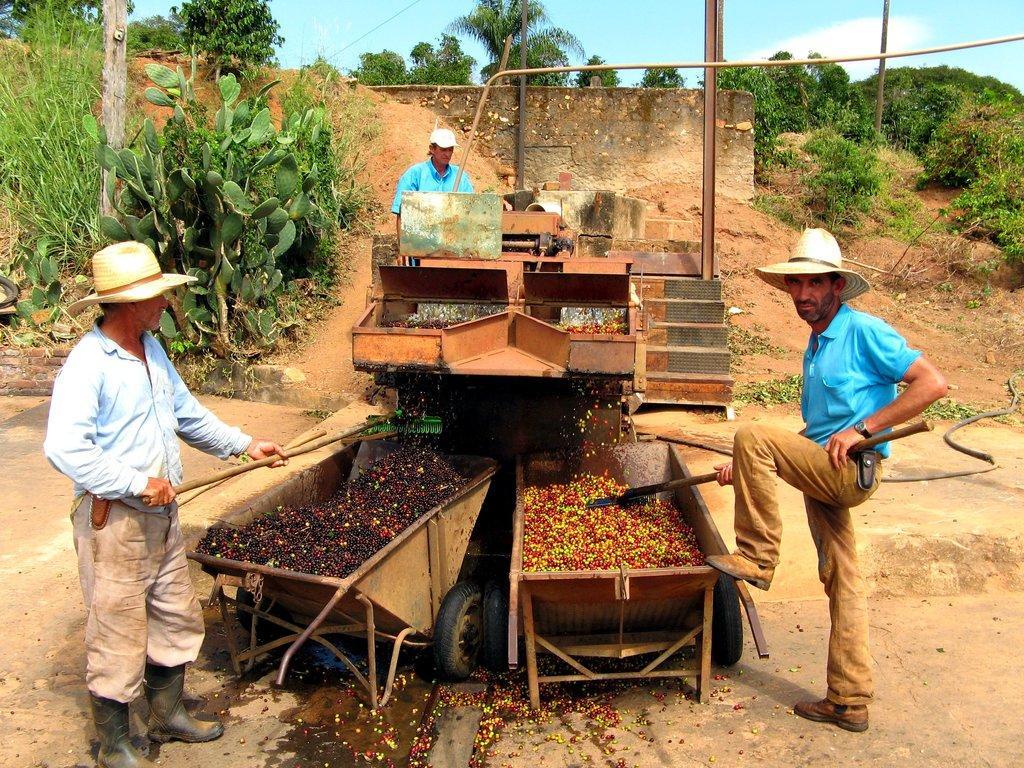Please provide a concise description of this image. In this picture, we see a man in a blue shirt who is wearing a hat is standing beside the trolley. There are trolleys containing fruits. We even see a machinery equipment. In the background, there are trees, a pole and a wall. On the left side of the picture, we see a man in blue shirt is holding a wooden stick in his hand. 